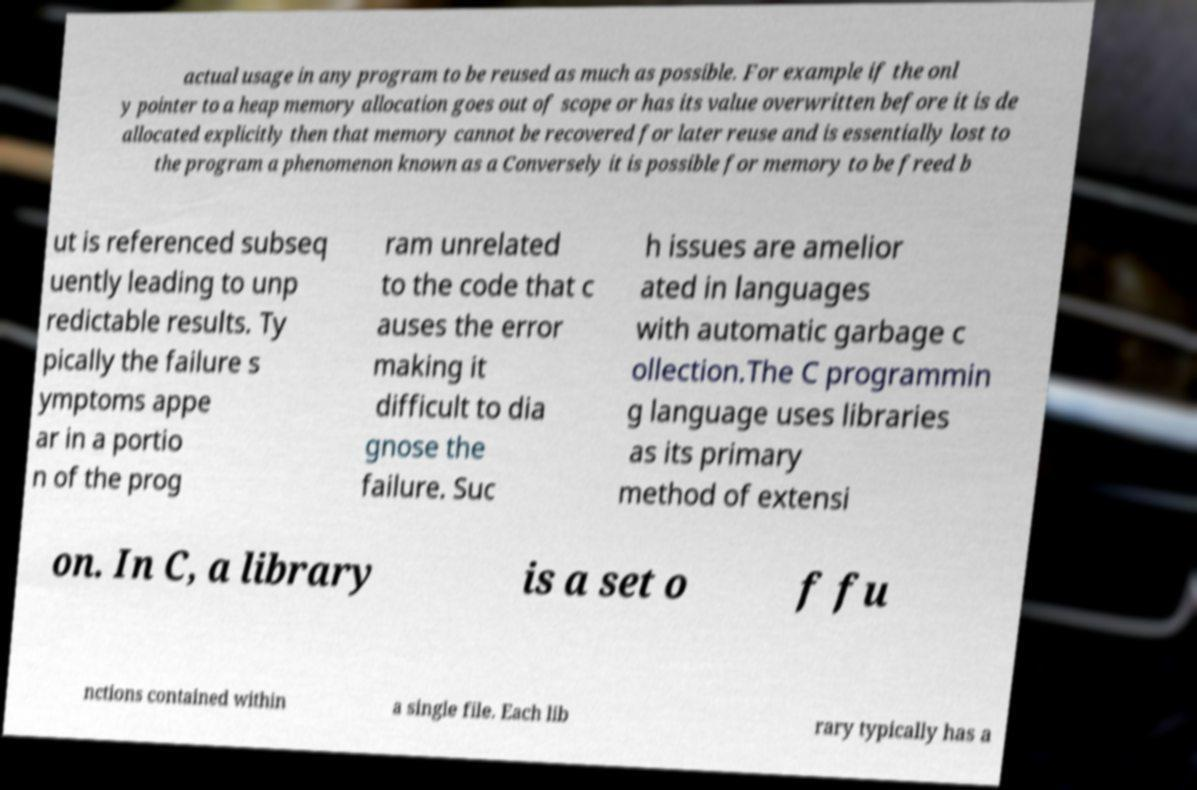Please read and relay the text visible in this image. What does it say? actual usage in any program to be reused as much as possible. For example if the onl y pointer to a heap memory allocation goes out of scope or has its value overwritten before it is de allocated explicitly then that memory cannot be recovered for later reuse and is essentially lost to the program a phenomenon known as a Conversely it is possible for memory to be freed b ut is referenced subseq uently leading to unp redictable results. Ty pically the failure s ymptoms appe ar in a portio n of the prog ram unrelated to the code that c auses the error making it difficult to dia gnose the failure. Suc h issues are amelior ated in languages with automatic garbage c ollection.The C programmin g language uses libraries as its primary method of extensi on. In C, a library is a set o f fu nctions contained within a single file. Each lib rary typically has a 